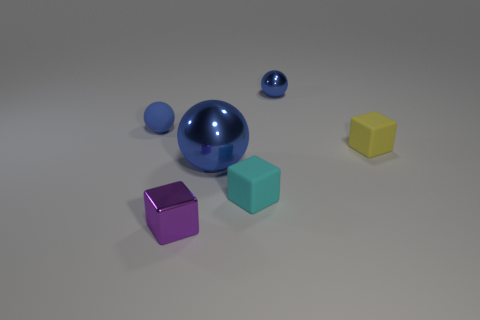Subtract all shiny spheres. How many spheres are left? 1 Subtract all yellow cubes. How many cubes are left? 2 Subtract 2 spheres. How many spheres are left? 1 Subtract all brown spheres. How many yellow cubes are left? 1 Subtract all large blue rubber cubes. Subtract all tiny blue spheres. How many objects are left? 4 Add 4 tiny yellow objects. How many tiny yellow objects are left? 5 Add 3 large blue metal spheres. How many large blue metal spheres exist? 4 Add 2 cyan things. How many objects exist? 8 Subtract 0 gray cylinders. How many objects are left? 6 Subtract all red cubes. Subtract all yellow cylinders. How many cubes are left? 3 